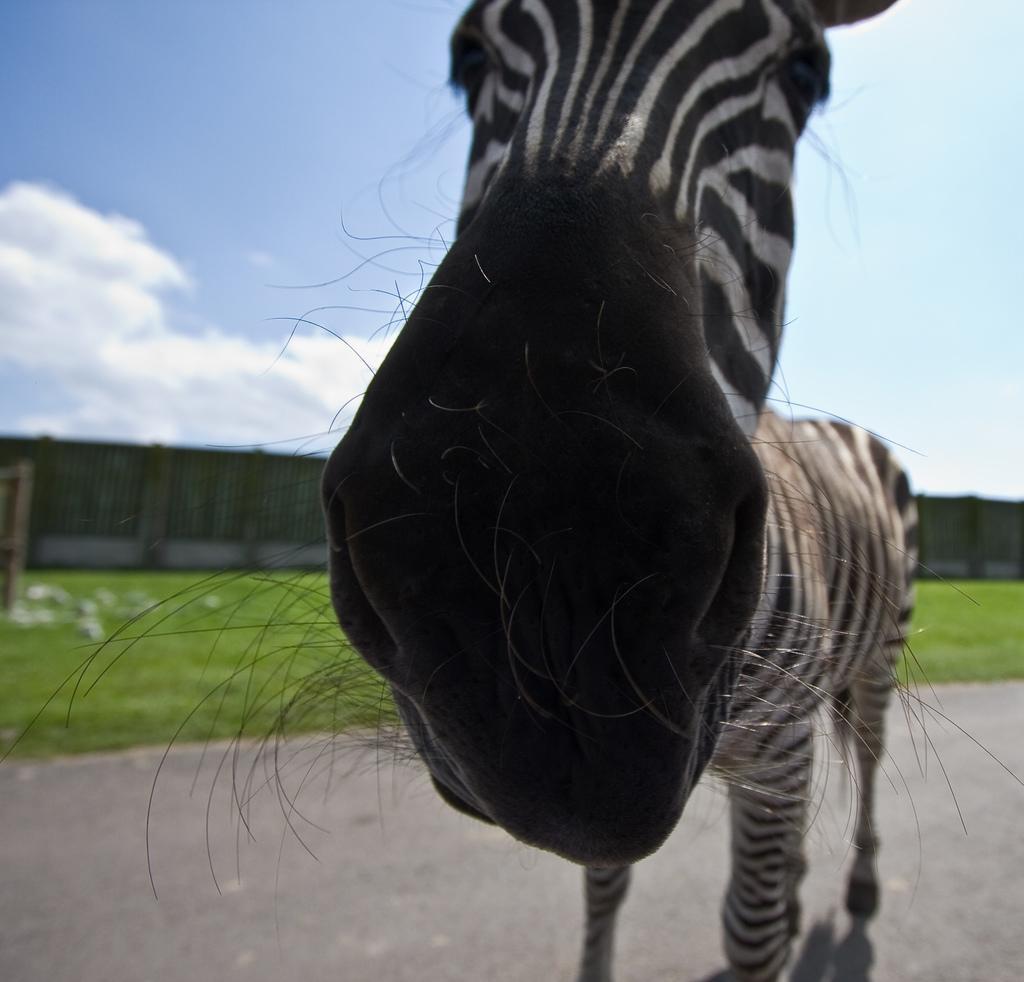How would you summarize this image in a sentence or two? In the center of the image there is a zebra on the road. In the background we can see grass, fencing, sky and wall. 